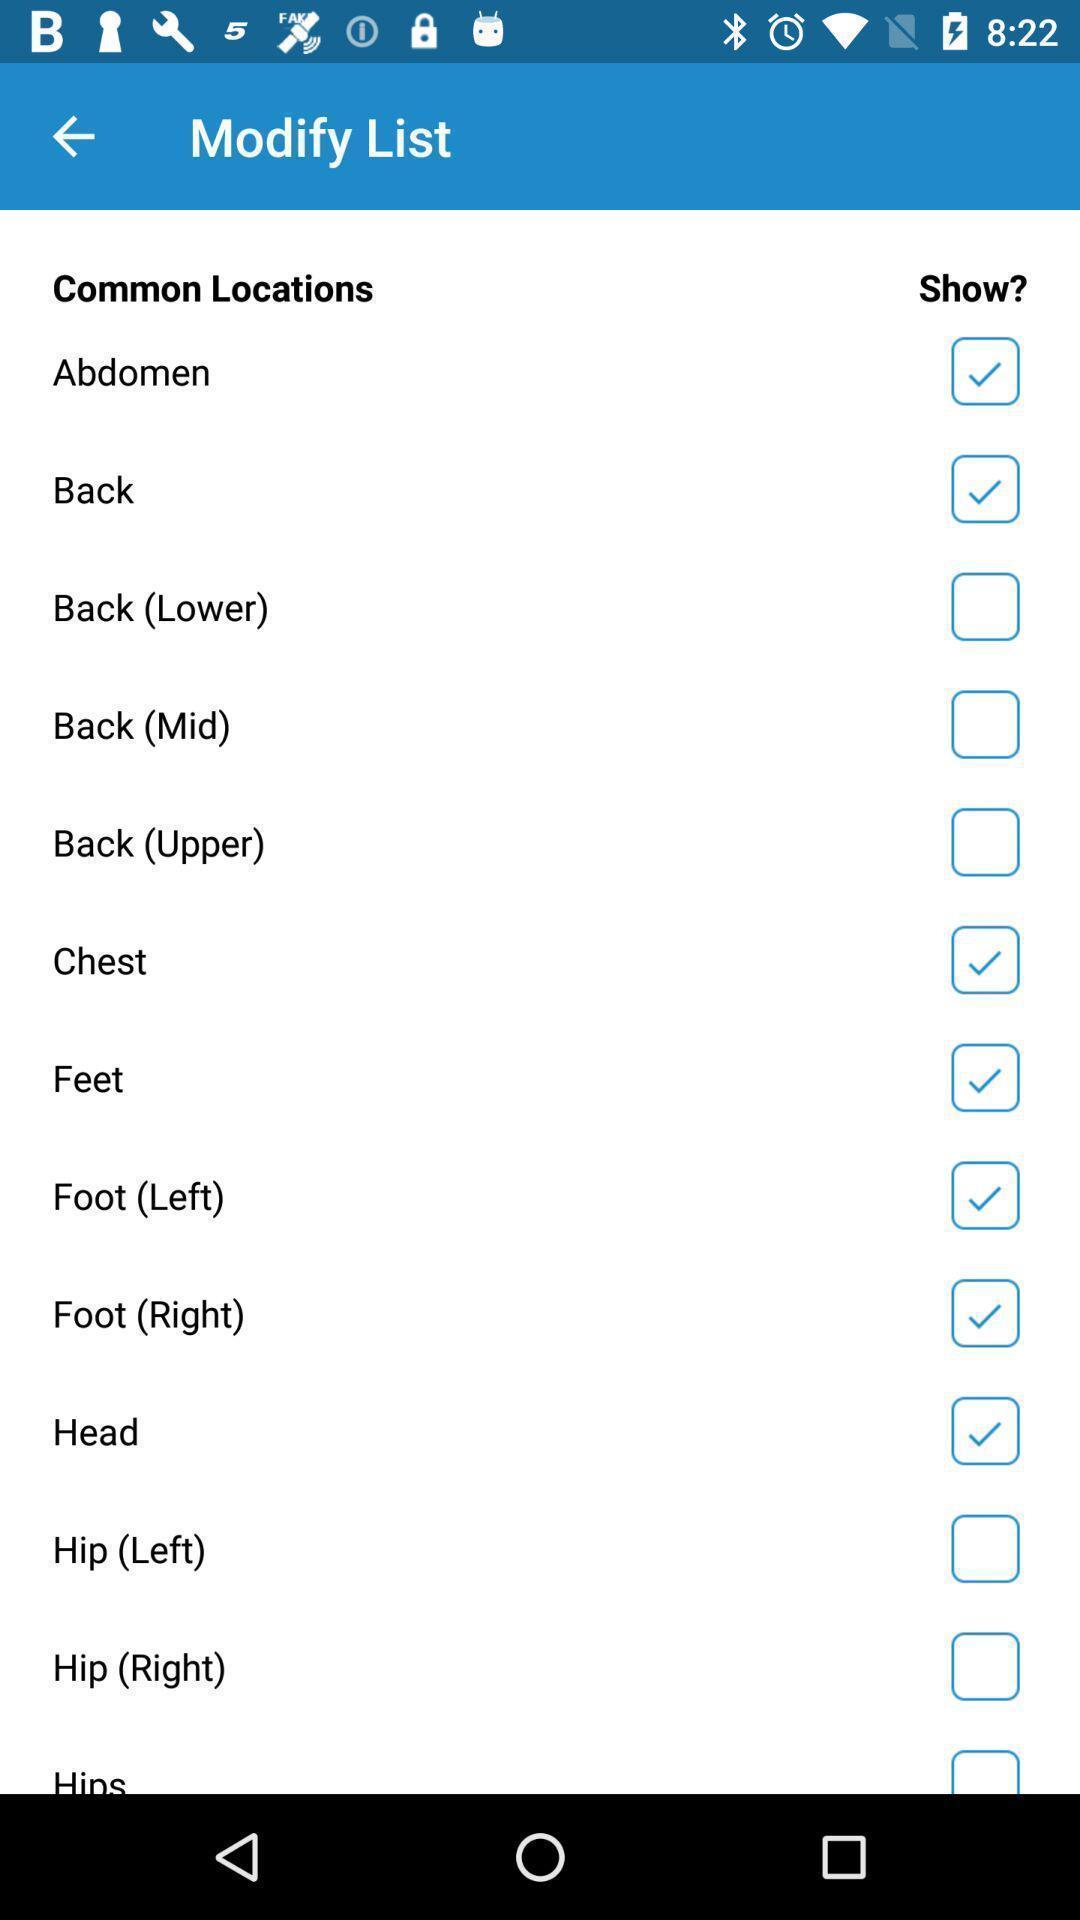Give me a summary of this screen capture. Screen shows modify list in a health app. 